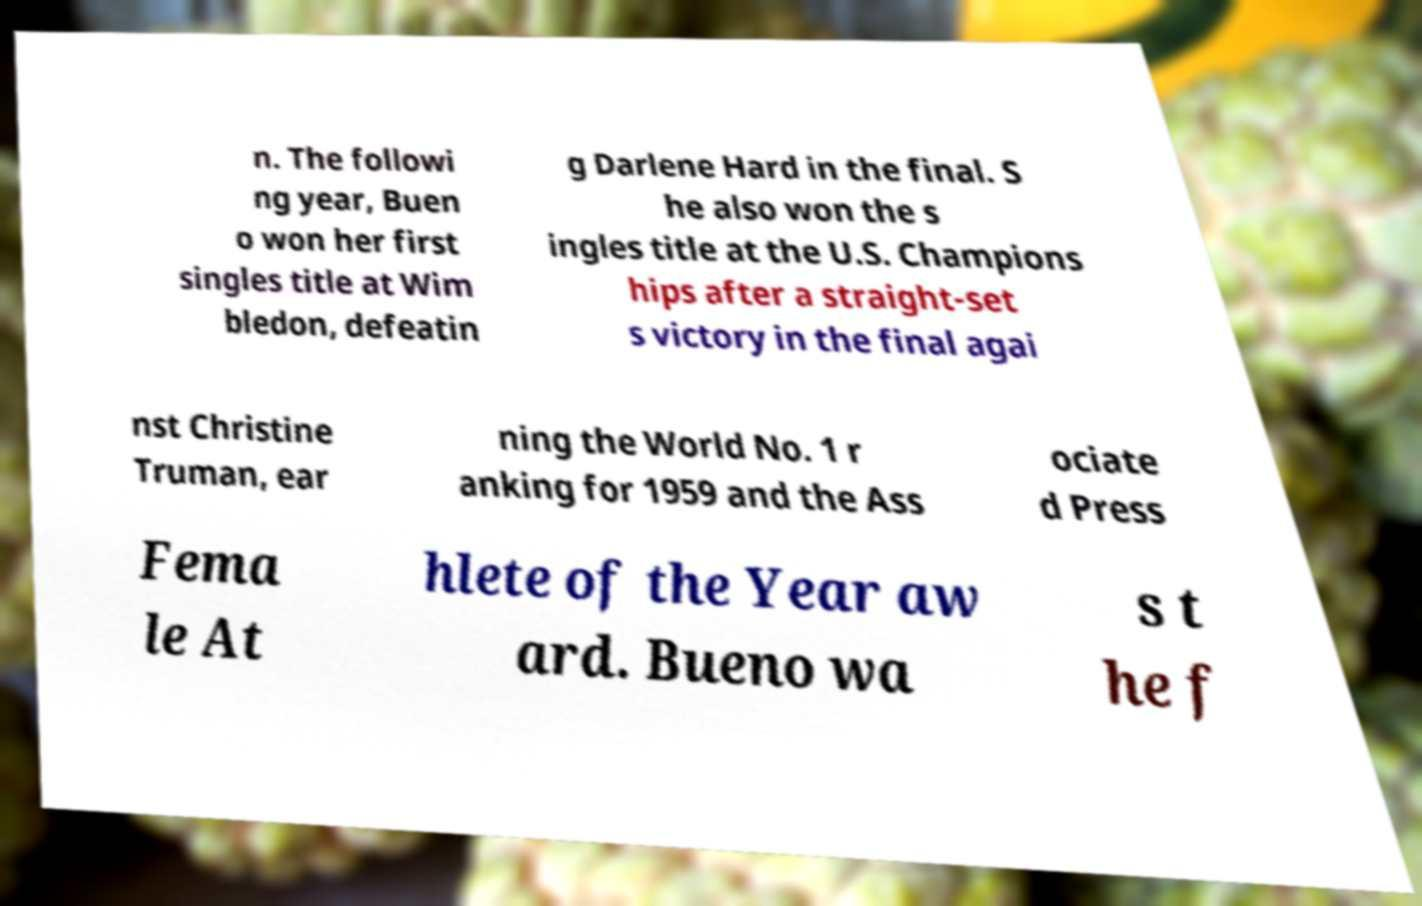Please read and relay the text visible in this image. What does it say? n. The followi ng year, Buen o won her first singles title at Wim bledon, defeatin g Darlene Hard in the final. S he also won the s ingles title at the U.S. Champions hips after a straight-set s victory in the final agai nst Christine Truman, ear ning the World No. 1 r anking for 1959 and the Ass ociate d Press Fema le At hlete of the Year aw ard. Bueno wa s t he f 